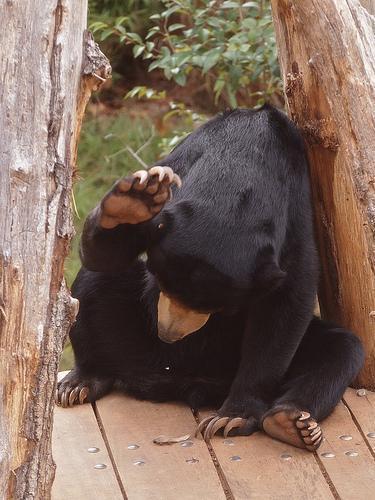How many nails are visible in the planks of wood?
Give a very brief answer. 15. How many trees are shown?
Give a very brief answer. 2. 